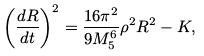Convert formula to latex. <formula><loc_0><loc_0><loc_500><loc_500>\left ( \frac { d R } { d t } \right ) ^ { 2 } = \frac { 1 6 \pi ^ { 2 } } { 9 M ^ { 6 } _ { 5 } } \rho ^ { 2 } R ^ { 2 } - K ,</formula> 